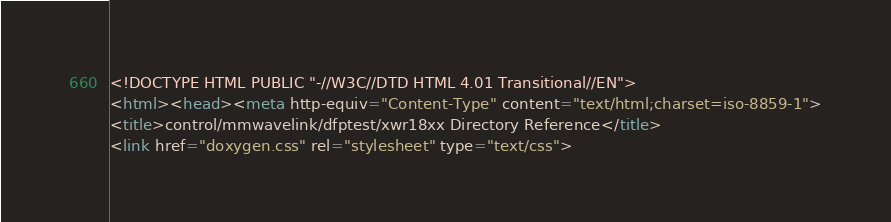<code> <loc_0><loc_0><loc_500><loc_500><_HTML_><!DOCTYPE HTML PUBLIC "-//W3C//DTD HTML 4.01 Transitional//EN">
<html><head><meta http-equiv="Content-Type" content="text/html;charset=iso-8859-1">
<title>control/mmwavelink/dfptest/xwr18xx Directory Reference</title>
<link href="doxygen.css" rel="stylesheet" type="text/css"></code> 